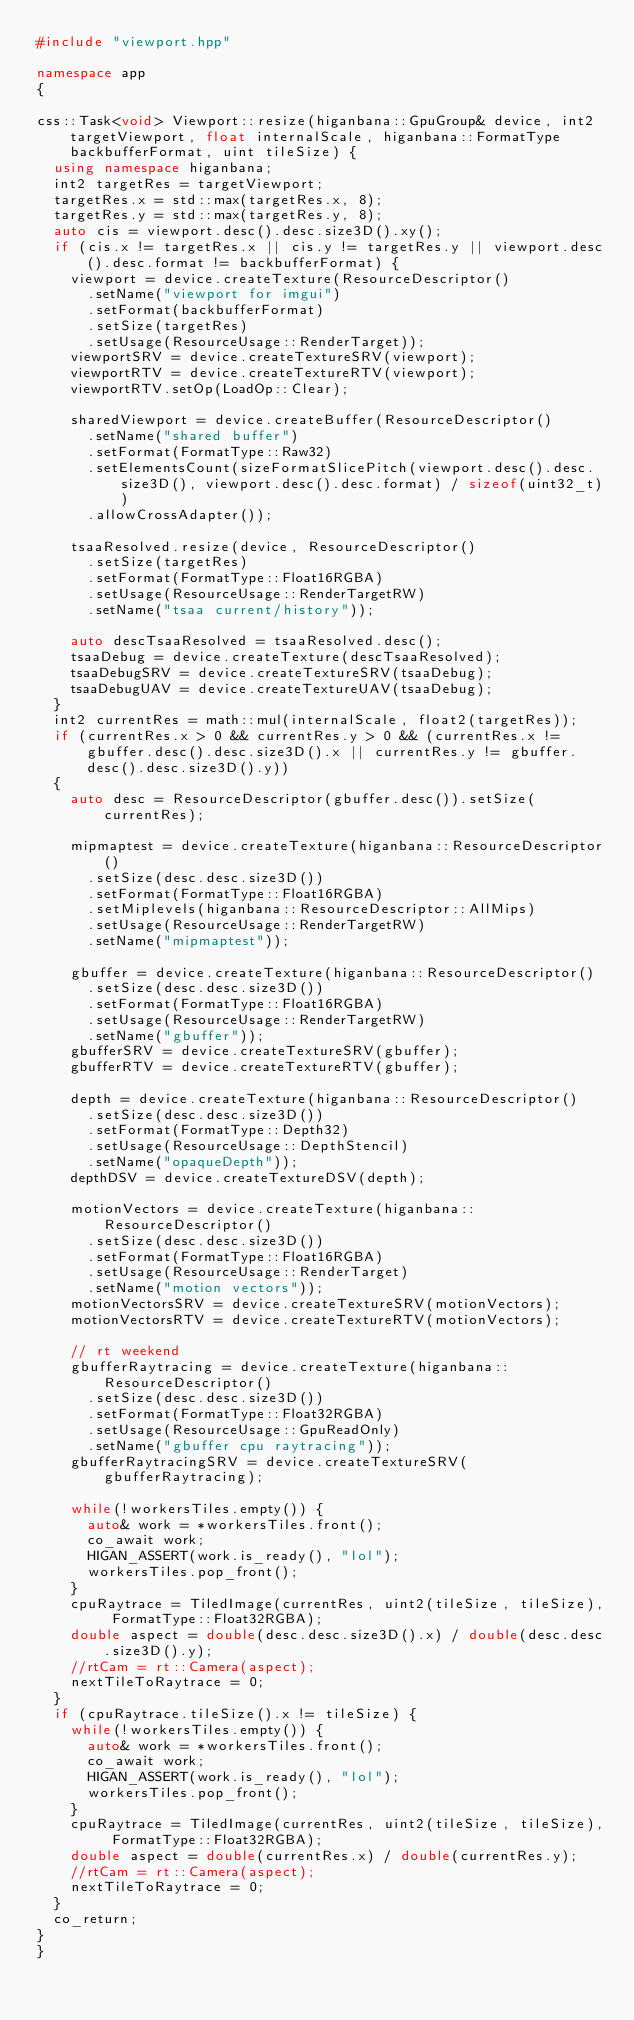Convert code to text. <code><loc_0><loc_0><loc_500><loc_500><_C++_>#include "viewport.hpp"

namespace app
{

css::Task<void> Viewport::resize(higanbana::GpuGroup& device, int2 targetViewport, float internalScale, higanbana::FormatType backbufferFormat, uint tileSize) {
  using namespace higanbana;
  int2 targetRes = targetViewport; 
  targetRes.x = std::max(targetRes.x, 8);
  targetRes.y = std::max(targetRes.y, 8);
  auto cis = viewport.desc().desc.size3D().xy();
  if (cis.x != targetRes.x || cis.y != targetRes.y || viewport.desc().desc.format != backbufferFormat) {
    viewport = device.createTexture(ResourceDescriptor()
      .setName("viewport for imgui")
      .setFormat(backbufferFormat)
      .setSize(targetRes)
      .setUsage(ResourceUsage::RenderTarget));
    viewportSRV = device.createTextureSRV(viewport);
    viewportRTV = device.createTextureRTV(viewport);
    viewportRTV.setOp(LoadOp::Clear);

    sharedViewport = device.createBuffer(ResourceDescriptor()
      .setName("shared buffer")
      .setFormat(FormatType::Raw32)
      .setElementsCount(sizeFormatSlicePitch(viewport.desc().desc.size3D(), viewport.desc().desc.format) / sizeof(uint32_t))
      .allowCrossAdapter());
    
    tsaaResolved.resize(device, ResourceDescriptor()
      .setSize(targetRes)
      .setFormat(FormatType::Float16RGBA)
      .setUsage(ResourceUsage::RenderTargetRW)
      .setName("tsaa current/history"));

    auto descTsaaResolved = tsaaResolved.desc();
    tsaaDebug = device.createTexture(descTsaaResolved);
    tsaaDebugSRV = device.createTextureSRV(tsaaDebug);
    tsaaDebugUAV = device.createTextureUAV(tsaaDebug);
  }
  int2 currentRes = math::mul(internalScale, float2(targetRes));
  if (currentRes.x > 0 && currentRes.y > 0 && (currentRes.x != gbuffer.desc().desc.size3D().x || currentRes.y != gbuffer.desc().desc.size3D().y))
  {
    auto desc = ResourceDescriptor(gbuffer.desc()).setSize(currentRes);

    mipmaptest = device.createTexture(higanbana::ResourceDescriptor()
      .setSize(desc.desc.size3D())
      .setFormat(FormatType::Float16RGBA)
      .setMiplevels(higanbana::ResourceDescriptor::AllMips)
      .setUsage(ResourceUsage::RenderTargetRW)
      .setName("mipmaptest"));

    gbuffer = device.createTexture(higanbana::ResourceDescriptor()
      .setSize(desc.desc.size3D())
      .setFormat(FormatType::Float16RGBA)
      .setUsage(ResourceUsage::RenderTargetRW)
      .setName("gbuffer"));
    gbufferSRV = device.createTextureSRV(gbuffer);
    gbufferRTV = device.createTextureRTV(gbuffer);

    depth = device.createTexture(higanbana::ResourceDescriptor()
      .setSize(desc.desc.size3D())
      .setFormat(FormatType::Depth32)
      .setUsage(ResourceUsage::DepthStencil)
      .setName("opaqueDepth"));
    depthDSV = device.createTextureDSV(depth);

    motionVectors = device.createTexture(higanbana::ResourceDescriptor()
      .setSize(desc.desc.size3D())
      .setFormat(FormatType::Float16RGBA)
      .setUsage(ResourceUsage::RenderTarget)
      .setName("motion vectors"));
    motionVectorsSRV = device.createTextureSRV(motionVectors);
    motionVectorsRTV = device.createTextureRTV(motionVectors);

    // rt weekend
    gbufferRaytracing = device.createTexture(higanbana::ResourceDescriptor()
      .setSize(desc.desc.size3D())
      .setFormat(FormatType::Float32RGBA)
      .setUsage(ResourceUsage::GpuReadOnly)
      .setName("gbuffer cpu raytracing"));
    gbufferRaytracingSRV = device.createTextureSRV(gbufferRaytracing);

    while(!workersTiles.empty()) {
      auto& work = *workersTiles.front();
      co_await work;
      HIGAN_ASSERT(work.is_ready(), "lol");
      workersTiles.pop_front();
    }
    cpuRaytrace = TiledImage(currentRes, uint2(tileSize, tileSize), FormatType::Float32RGBA);
    double aspect = double(desc.desc.size3D().x) / double(desc.desc.size3D().y);
    //rtCam = rt::Camera(aspect);
    nextTileToRaytrace = 0;
  }
  if (cpuRaytrace.tileSize().x != tileSize) {
    while(!workersTiles.empty()) {
      auto& work = *workersTiles.front();
      co_await work;
      HIGAN_ASSERT(work.is_ready(), "lol");
      workersTiles.pop_front();
    }
    cpuRaytrace = TiledImage(currentRes, uint2(tileSize, tileSize), FormatType::Float32RGBA);
    double aspect = double(currentRes.x) / double(currentRes.y);
    //rtCam = rt::Camera(aspect);
    nextTileToRaytrace = 0;
  }
  co_return;
}
}</code> 